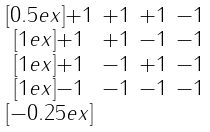Convert formula to latex. <formula><loc_0><loc_0><loc_500><loc_500>\begin{smallmatrix} & & & \\ [ 0 . 5 e x ] + 1 & + 1 & + 1 & - 1 \\ [ 1 e x ] + 1 & + 1 & - 1 & - 1 \\ [ 1 e x ] + 1 & - 1 & + 1 & - 1 \\ [ 1 e x ] - 1 & - 1 & - 1 & - 1 \\ [ - 0 . 2 5 e x ] & & & \end{smallmatrix}</formula> 